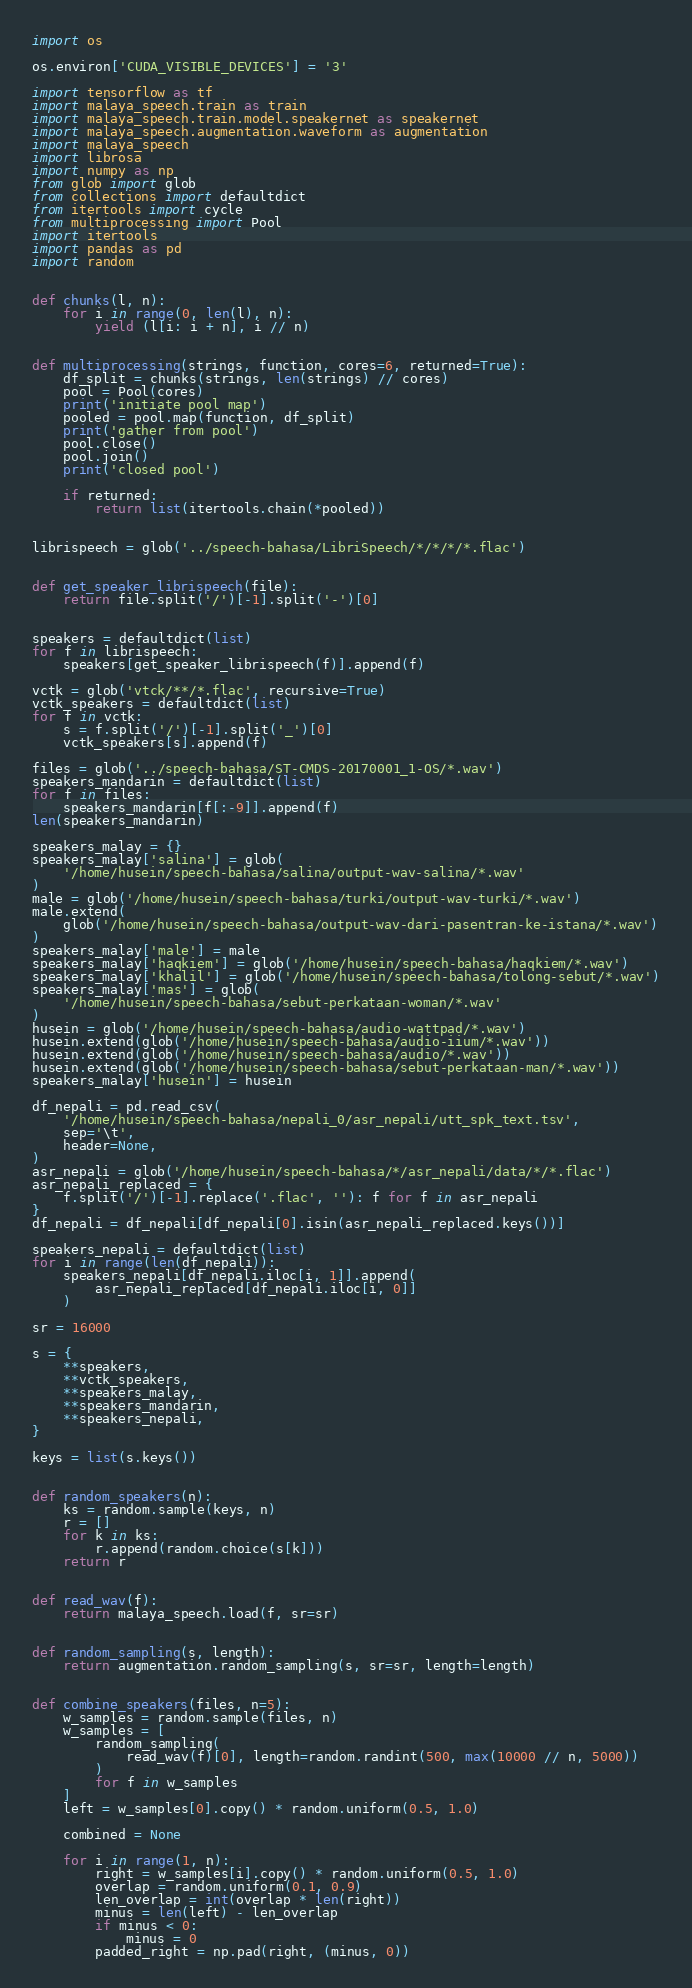<code> <loc_0><loc_0><loc_500><loc_500><_Python_>import os

os.environ['CUDA_VISIBLE_DEVICES'] = '3'

import tensorflow as tf
import malaya_speech.train as train
import malaya_speech.train.model.speakernet as speakernet
import malaya_speech.augmentation.waveform as augmentation
import malaya_speech
import librosa
import numpy as np
from glob import glob
from collections import defaultdict
from itertools import cycle
from multiprocessing import Pool
import itertools
import pandas as pd
import random


def chunks(l, n):
    for i in range(0, len(l), n):
        yield (l[i: i + n], i // n)


def multiprocessing(strings, function, cores=6, returned=True):
    df_split = chunks(strings, len(strings) // cores)
    pool = Pool(cores)
    print('initiate pool map')
    pooled = pool.map(function, df_split)
    print('gather from pool')
    pool.close()
    pool.join()
    print('closed pool')

    if returned:
        return list(itertools.chain(*pooled))


librispeech = glob('../speech-bahasa/LibriSpeech/*/*/*/*.flac')


def get_speaker_librispeech(file):
    return file.split('/')[-1].split('-')[0]


speakers = defaultdict(list)
for f in librispeech:
    speakers[get_speaker_librispeech(f)].append(f)

vctk = glob('vtck/**/*.flac', recursive=True)
vctk_speakers = defaultdict(list)
for f in vctk:
    s = f.split('/')[-1].split('_')[0]
    vctk_speakers[s].append(f)

files = glob('../speech-bahasa/ST-CMDS-20170001_1-OS/*.wav')
speakers_mandarin = defaultdict(list)
for f in files:
    speakers_mandarin[f[:-9]].append(f)
len(speakers_mandarin)

speakers_malay = {}
speakers_malay['salina'] = glob(
    '/home/husein/speech-bahasa/salina/output-wav-salina/*.wav'
)
male = glob('/home/husein/speech-bahasa/turki/output-wav-turki/*.wav')
male.extend(
    glob('/home/husein/speech-bahasa/output-wav-dari-pasentran-ke-istana/*.wav')
)
speakers_malay['male'] = male
speakers_malay['haqkiem'] = glob('/home/husein/speech-bahasa/haqkiem/*.wav')
speakers_malay['khalil'] = glob('/home/husein/speech-bahasa/tolong-sebut/*.wav')
speakers_malay['mas'] = glob(
    '/home/husein/speech-bahasa/sebut-perkataan-woman/*.wav'
)
husein = glob('/home/husein/speech-bahasa/audio-wattpad/*.wav')
husein.extend(glob('/home/husein/speech-bahasa/audio-iium/*.wav'))
husein.extend(glob('/home/husein/speech-bahasa/audio/*.wav'))
husein.extend(glob('/home/husein/speech-bahasa/sebut-perkataan-man/*.wav'))
speakers_malay['husein'] = husein

df_nepali = pd.read_csv(
    '/home/husein/speech-bahasa/nepali_0/asr_nepali/utt_spk_text.tsv',
    sep='\t',
    header=None,
)
asr_nepali = glob('/home/husein/speech-bahasa/*/asr_nepali/data/*/*.flac')
asr_nepali_replaced = {
    f.split('/')[-1].replace('.flac', ''): f for f in asr_nepali
}
df_nepali = df_nepali[df_nepali[0].isin(asr_nepali_replaced.keys())]

speakers_nepali = defaultdict(list)
for i in range(len(df_nepali)):
    speakers_nepali[df_nepali.iloc[i, 1]].append(
        asr_nepali_replaced[df_nepali.iloc[i, 0]]
    )

sr = 16000

s = {
    **speakers,
    **vctk_speakers,
    **speakers_malay,
    **speakers_mandarin,
    **speakers_nepali,
}

keys = list(s.keys())


def random_speakers(n):
    ks = random.sample(keys, n)
    r = []
    for k in ks:
        r.append(random.choice(s[k]))
    return r


def read_wav(f):
    return malaya_speech.load(f, sr=sr)


def random_sampling(s, length):
    return augmentation.random_sampling(s, sr=sr, length=length)


def combine_speakers(files, n=5):
    w_samples = random.sample(files, n)
    w_samples = [
        random_sampling(
            read_wav(f)[0], length=random.randint(500, max(10000 // n, 5000))
        )
        for f in w_samples
    ]
    left = w_samples[0].copy() * random.uniform(0.5, 1.0)

    combined = None

    for i in range(1, n):
        right = w_samples[i].copy() * random.uniform(0.5, 1.0)
        overlap = random.uniform(0.1, 0.9)
        len_overlap = int(overlap * len(right))
        minus = len(left) - len_overlap
        if minus < 0:
            minus = 0
        padded_right = np.pad(right, (minus, 0))</code> 